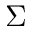Convert formula to latex. <formula><loc_0><loc_0><loc_500><loc_500>\Sigma</formula> 